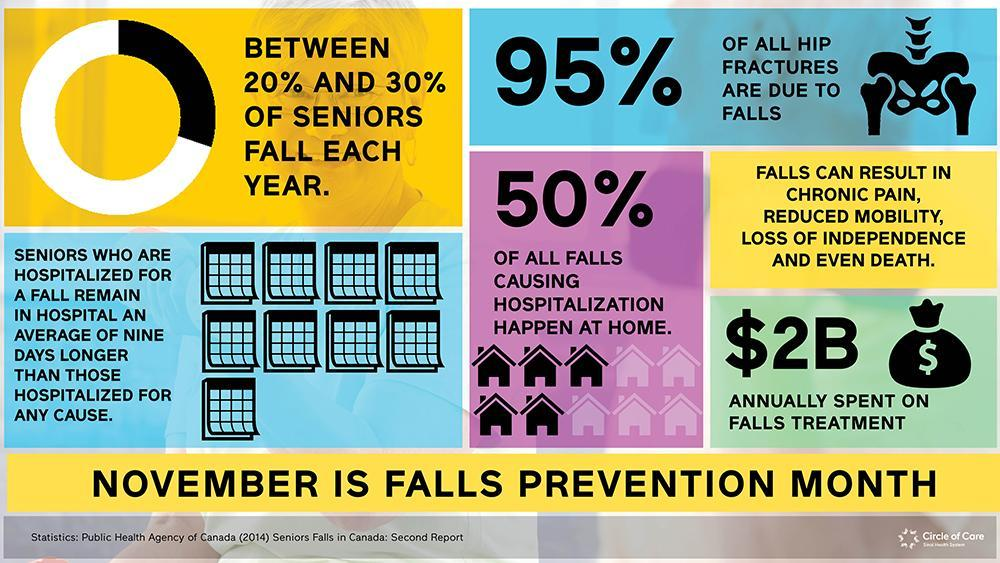How many icons of houses are given in this infographic?
Answer the question with a short phrase. 10 what is the percentage of hip fractures that are not caused by falls? 5 How many icons of black houses are given in this infographic? 5 what is the percentage of hip fractures that are happened at places other than home? 50% How many $ symbols are given in this infographic? 2 